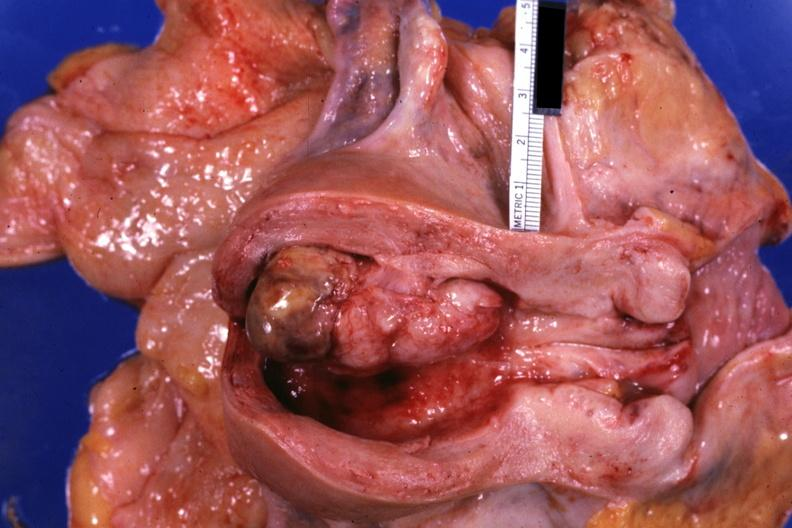what is present?
Answer the question using a single word or phrase. Mixed mesodermal tumor 